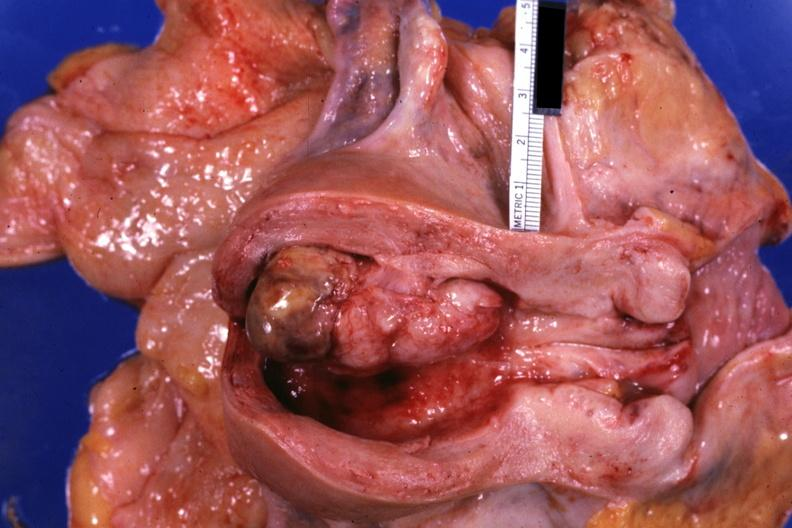what is present?
Answer the question using a single word or phrase. Mixed mesodermal tumor 